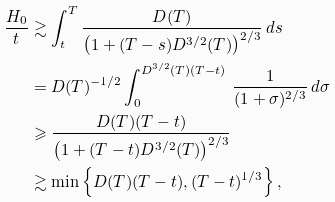<formula> <loc_0><loc_0><loc_500><loc_500>\frac { H _ { 0 } } { t } & \gtrsim \int _ { t } ^ { T } \frac { D ( T ) } { \left ( 1 + ( T - s ) D ^ { 3 / 2 } ( T ) \right ) ^ { 2 / 3 } } \, d s \\ & = D ( T ) ^ { - 1 / 2 } \int _ { 0 } ^ { D ^ { 3 / 2 } ( T ) ( T - t ) } \, \frac { 1 } { ( 1 + \sigma ) ^ { 2 / 3 } } \, d \sigma \\ & \geqslant \frac { D ( T ) ( T - t ) } { \left ( 1 + ( T - t ) D ^ { 3 / 2 } ( T ) \right ) ^ { 2 / 3 } } \\ & \gtrsim \min \left \{ D ( T ) ( T - t ) , ( T - t ) ^ { 1 / 3 } \right \} ,</formula> 